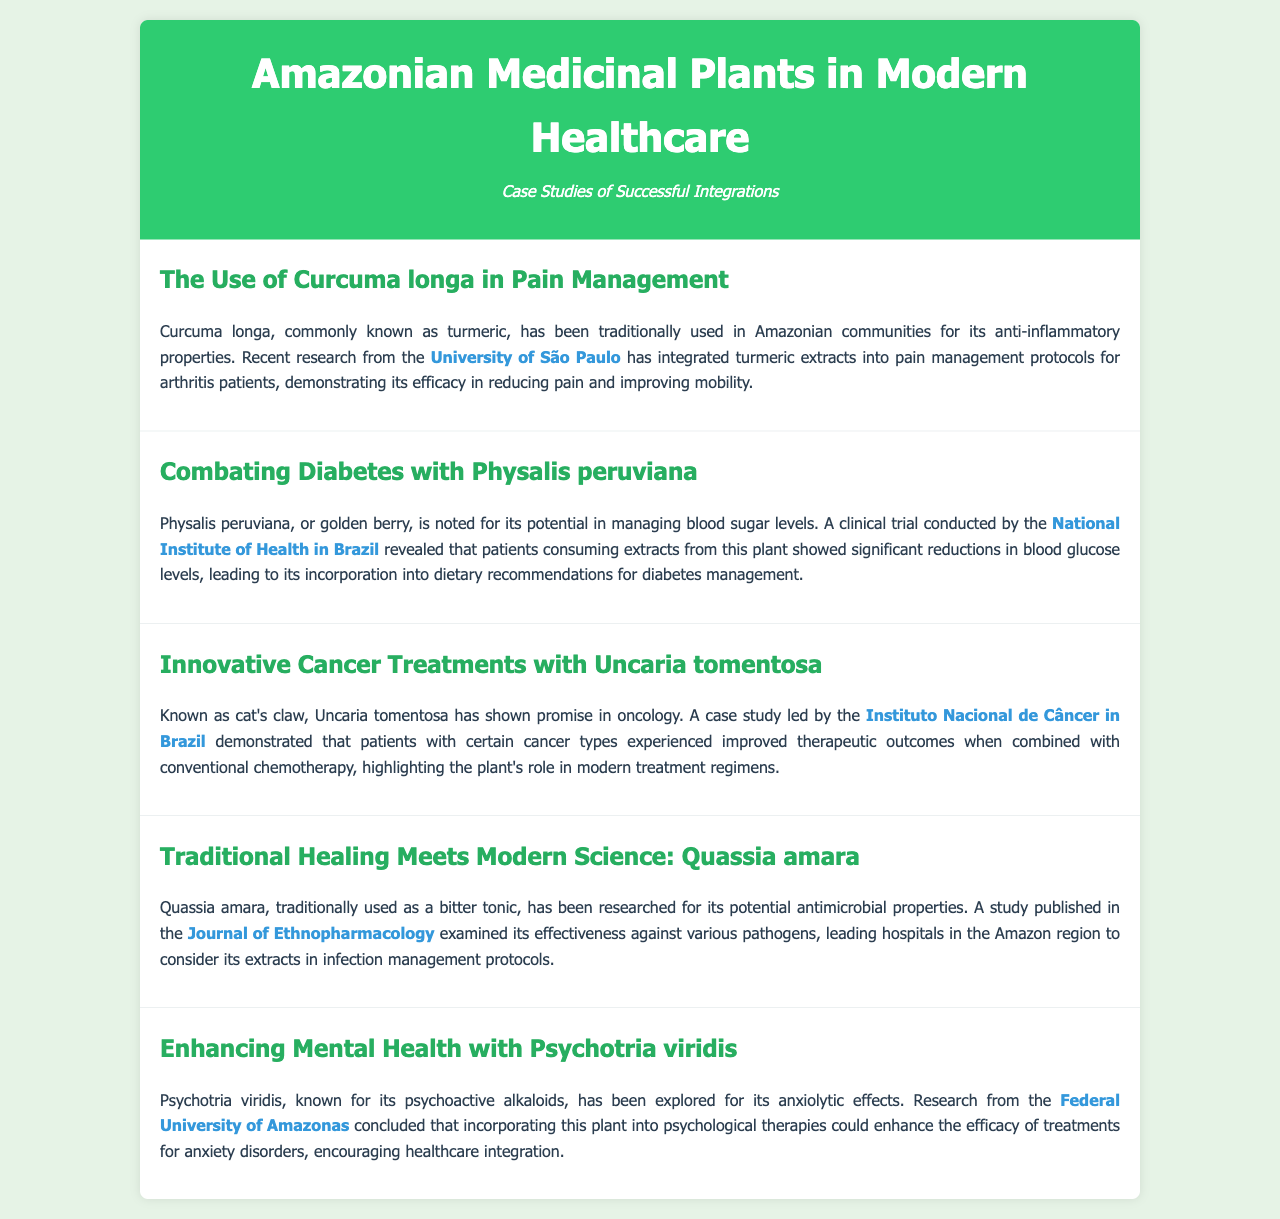What is the title of the report? The title is described in the header section of the document, which states the focus on Amazonian medicinal plants and modern healthcare.
Answer: Amazonian Medicinal Plants in Modern Healthcare Which plant is used for pain management? The plant mentioned for pain management in the document is Curcuma longa, which is traditionally used for its anti-inflammatory properties.
Answer: Curcuma longa What institution conducted research on Physalis peruviana? The document specifies that research on Physalis peruviana was conducted by the National Institute of Health in Brazil.
Answer: National Institute of Health in Brazil What benefit does Uncaria tomentosa have according to the case study? The document notes that Uncaria tomentosa has improved therapeutic outcomes when combined with conventional chemotherapy in certain cancer types.
Answer: Improved therapeutic outcomes What type of properties is Quassia amara known for? The document states that Quassia amara is traditionally used as a bitter tonic and has been researched for antimicrobial properties.
Answer: Antimicrobial properties Which research institution studied the mental health benefits of Psychotria viridis? The research on Psychotria viridis and its potential anxiolytic effects was conducted by the Federal University of Amazonas.
Answer: Federal University of Amazonas 